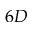Convert formula to latex. <formula><loc_0><loc_0><loc_500><loc_500>6 D</formula> 